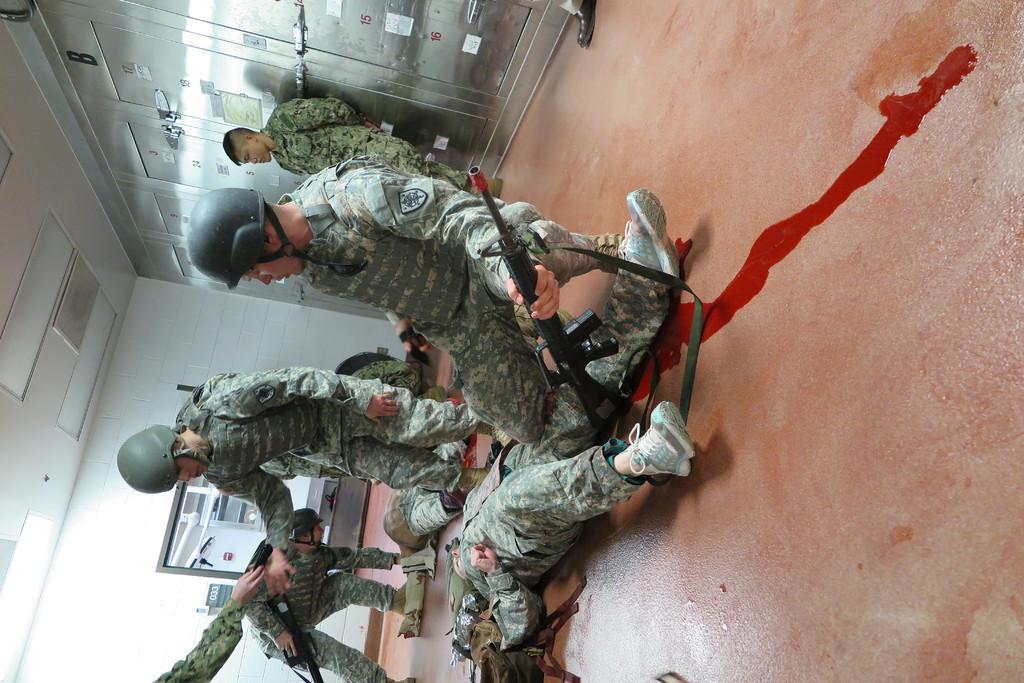Can you describe this image briefly? In this image, I can see two persons lying on the floor, three persons standing and two persons in squat position. At the bottom of the image, I can see a person's hand. At the top of the image, I can see the cupboards. On the left side of the image, there is a television and I can see the ceiling lights attached to the ceiling. 